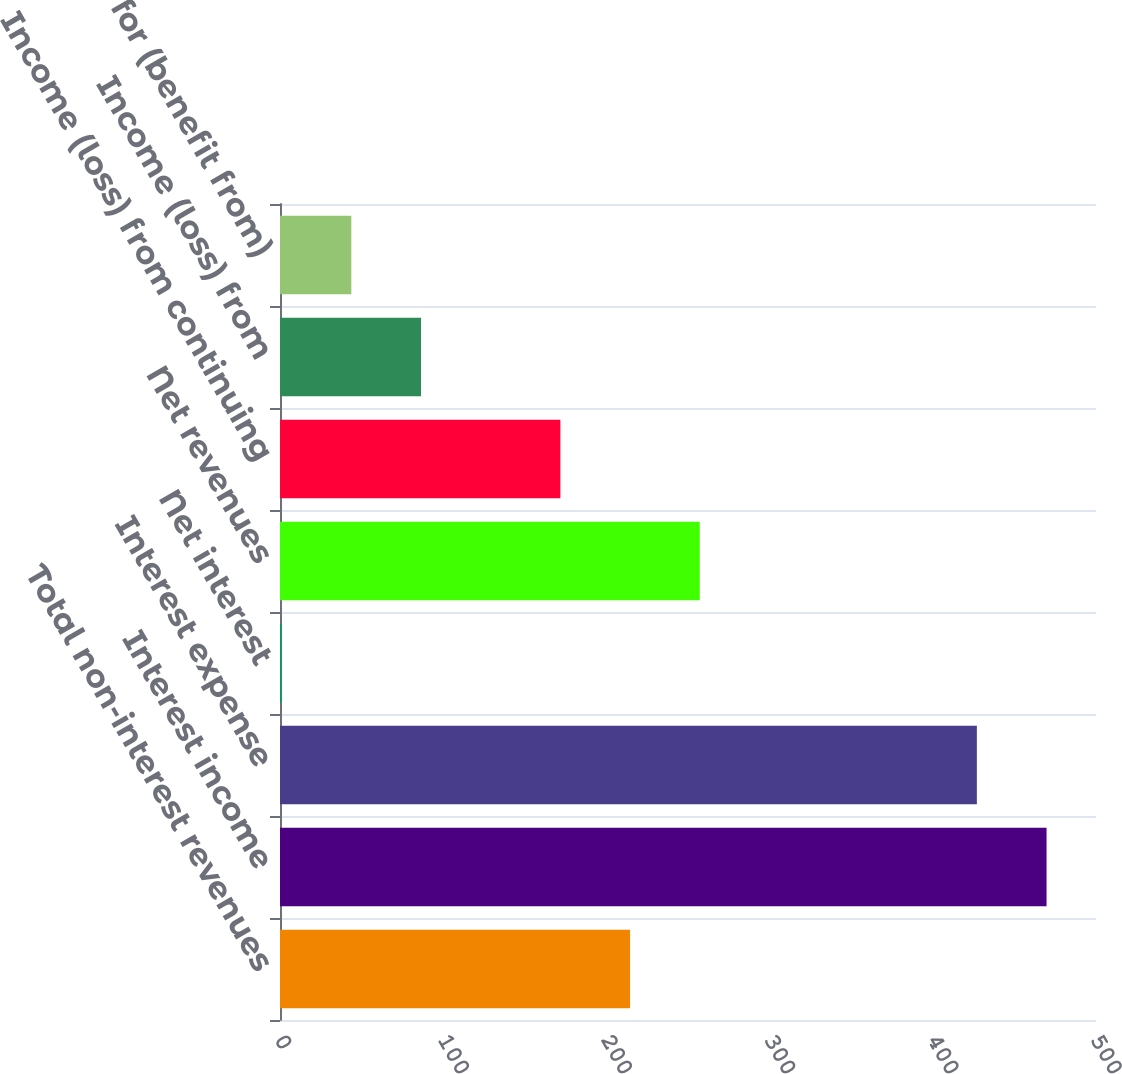Convert chart to OTSL. <chart><loc_0><loc_0><loc_500><loc_500><bar_chart><fcel>Total non-interest revenues<fcel>Interest income<fcel>Interest expense<fcel>Net interest<fcel>Net revenues<fcel>Income (loss) from continuing<fcel>Income (loss) from<fcel>Provision for (benefit from)<nl><fcel>214.5<fcel>469.7<fcel>427<fcel>1<fcel>257.2<fcel>171.8<fcel>86.4<fcel>43.7<nl></chart> 